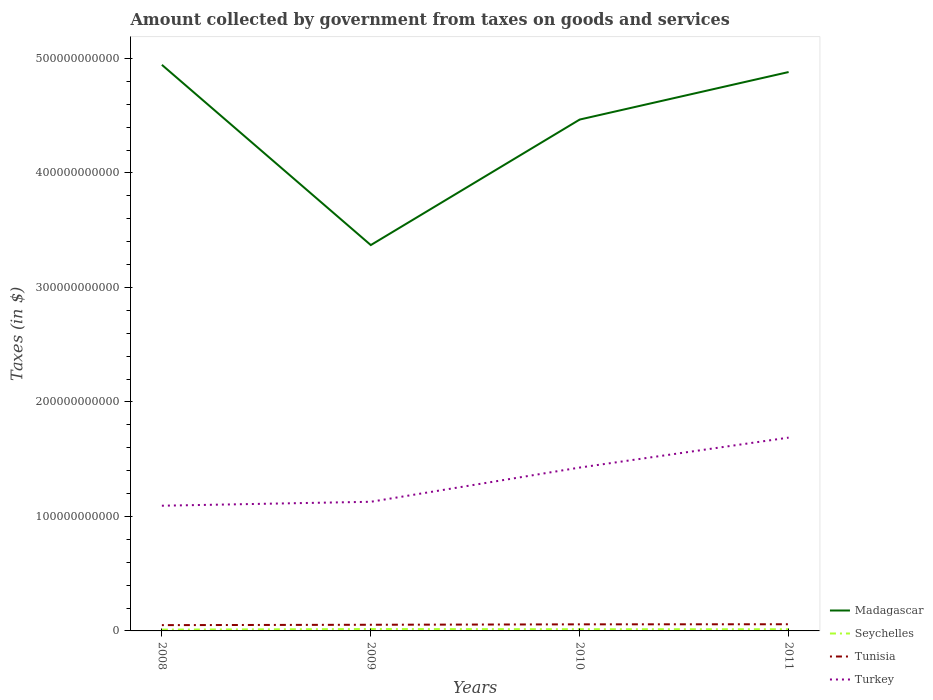Is the number of lines equal to the number of legend labels?
Provide a short and direct response. Yes. Across all years, what is the maximum amount collected by government from taxes on goods and services in Tunisia?
Your answer should be compact. 5.06e+09. In which year was the amount collected by government from taxes on goods and services in Madagascar maximum?
Your response must be concise. 2009. What is the total amount collected by government from taxes on goods and services in Turkey in the graph?
Your answer should be compact. -2.99e+1. What is the difference between the highest and the second highest amount collected by government from taxes on goods and services in Tunisia?
Give a very brief answer. 7.66e+08. How many lines are there?
Your answer should be compact. 4. How many years are there in the graph?
Make the answer very short. 4. What is the difference between two consecutive major ticks on the Y-axis?
Offer a very short reply. 1.00e+11. Does the graph contain any zero values?
Keep it short and to the point. No. Does the graph contain grids?
Provide a short and direct response. No. How many legend labels are there?
Offer a very short reply. 4. What is the title of the graph?
Provide a succinct answer. Amount collected by government from taxes on goods and services. Does "Congo (Republic)" appear as one of the legend labels in the graph?
Your answer should be very brief. No. What is the label or title of the Y-axis?
Provide a succinct answer. Taxes (in $). What is the Taxes (in $) of Madagascar in 2008?
Your answer should be very brief. 4.94e+11. What is the Taxes (in $) in Seychelles in 2008?
Give a very brief answer. 1.15e+09. What is the Taxes (in $) in Tunisia in 2008?
Offer a terse response. 5.06e+09. What is the Taxes (in $) of Turkey in 2008?
Provide a short and direct response. 1.09e+11. What is the Taxes (in $) in Madagascar in 2009?
Ensure brevity in your answer.  3.37e+11. What is the Taxes (in $) of Seychelles in 2009?
Make the answer very short. 1.66e+09. What is the Taxes (in $) of Tunisia in 2009?
Ensure brevity in your answer.  5.38e+09. What is the Taxes (in $) of Turkey in 2009?
Your answer should be compact. 1.13e+11. What is the Taxes (in $) of Madagascar in 2010?
Your answer should be very brief. 4.47e+11. What is the Taxes (in $) of Seychelles in 2010?
Ensure brevity in your answer.  1.51e+09. What is the Taxes (in $) of Tunisia in 2010?
Ensure brevity in your answer.  5.75e+09. What is the Taxes (in $) in Turkey in 2010?
Your answer should be very brief. 1.43e+11. What is the Taxes (in $) in Madagascar in 2011?
Make the answer very short. 4.88e+11. What is the Taxes (in $) of Seychelles in 2011?
Provide a short and direct response. 1.48e+09. What is the Taxes (in $) in Tunisia in 2011?
Your answer should be compact. 5.83e+09. What is the Taxes (in $) in Turkey in 2011?
Keep it short and to the point. 1.69e+11. Across all years, what is the maximum Taxes (in $) of Madagascar?
Offer a terse response. 4.94e+11. Across all years, what is the maximum Taxes (in $) in Seychelles?
Make the answer very short. 1.66e+09. Across all years, what is the maximum Taxes (in $) in Tunisia?
Ensure brevity in your answer.  5.83e+09. Across all years, what is the maximum Taxes (in $) in Turkey?
Offer a very short reply. 1.69e+11. Across all years, what is the minimum Taxes (in $) of Madagascar?
Make the answer very short. 3.37e+11. Across all years, what is the minimum Taxes (in $) in Seychelles?
Give a very brief answer. 1.15e+09. Across all years, what is the minimum Taxes (in $) of Tunisia?
Provide a succinct answer. 5.06e+09. Across all years, what is the minimum Taxes (in $) of Turkey?
Your answer should be very brief. 1.09e+11. What is the total Taxes (in $) in Madagascar in the graph?
Offer a very short reply. 1.77e+12. What is the total Taxes (in $) of Seychelles in the graph?
Your response must be concise. 5.80e+09. What is the total Taxes (in $) of Tunisia in the graph?
Ensure brevity in your answer.  2.20e+1. What is the total Taxes (in $) of Turkey in the graph?
Keep it short and to the point. 5.34e+11. What is the difference between the Taxes (in $) of Madagascar in 2008 and that in 2009?
Provide a short and direct response. 1.57e+11. What is the difference between the Taxes (in $) in Seychelles in 2008 and that in 2009?
Provide a short and direct response. -5.13e+08. What is the difference between the Taxes (in $) of Tunisia in 2008 and that in 2009?
Give a very brief answer. -3.16e+08. What is the difference between the Taxes (in $) of Turkey in 2008 and that in 2009?
Your answer should be compact. -3.44e+09. What is the difference between the Taxes (in $) of Madagascar in 2008 and that in 2010?
Keep it short and to the point. 4.78e+1. What is the difference between the Taxes (in $) of Seychelles in 2008 and that in 2010?
Your answer should be compact. -3.64e+08. What is the difference between the Taxes (in $) in Tunisia in 2008 and that in 2010?
Your answer should be very brief. -6.86e+08. What is the difference between the Taxes (in $) of Turkey in 2008 and that in 2010?
Make the answer very short. -3.33e+1. What is the difference between the Taxes (in $) of Madagascar in 2008 and that in 2011?
Your answer should be compact. 6.30e+09. What is the difference between the Taxes (in $) of Seychelles in 2008 and that in 2011?
Ensure brevity in your answer.  -3.36e+08. What is the difference between the Taxes (in $) of Tunisia in 2008 and that in 2011?
Offer a very short reply. -7.66e+08. What is the difference between the Taxes (in $) in Turkey in 2008 and that in 2011?
Your response must be concise. -5.95e+1. What is the difference between the Taxes (in $) of Madagascar in 2009 and that in 2010?
Keep it short and to the point. -1.10e+11. What is the difference between the Taxes (in $) in Seychelles in 2009 and that in 2010?
Offer a very short reply. 1.49e+08. What is the difference between the Taxes (in $) in Tunisia in 2009 and that in 2010?
Give a very brief answer. -3.70e+08. What is the difference between the Taxes (in $) in Turkey in 2009 and that in 2010?
Provide a short and direct response. -2.99e+1. What is the difference between the Taxes (in $) of Madagascar in 2009 and that in 2011?
Your answer should be compact. -1.51e+11. What is the difference between the Taxes (in $) of Seychelles in 2009 and that in 2011?
Your answer should be very brief. 1.77e+08. What is the difference between the Taxes (in $) in Tunisia in 2009 and that in 2011?
Keep it short and to the point. -4.50e+08. What is the difference between the Taxes (in $) of Turkey in 2009 and that in 2011?
Give a very brief answer. -5.60e+1. What is the difference between the Taxes (in $) of Madagascar in 2010 and that in 2011?
Provide a short and direct response. -4.15e+1. What is the difference between the Taxes (in $) in Seychelles in 2010 and that in 2011?
Make the answer very short. 2.78e+07. What is the difference between the Taxes (in $) of Tunisia in 2010 and that in 2011?
Your answer should be compact. -7.98e+07. What is the difference between the Taxes (in $) of Turkey in 2010 and that in 2011?
Make the answer very short. -2.61e+1. What is the difference between the Taxes (in $) of Madagascar in 2008 and the Taxes (in $) of Seychelles in 2009?
Your response must be concise. 4.93e+11. What is the difference between the Taxes (in $) in Madagascar in 2008 and the Taxes (in $) in Tunisia in 2009?
Your response must be concise. 4.89e+11. What is the difference between the Taxes (in $) in Madagascar in 2008 and the Taxes (in $) in Turkey in 2009?
Make the answer very short. 3.82e+11. What is the difference between the Taxes (in $) in Seychelles in 2008 and the Taxes (in $) in Tunisia in 2009?
Offer a terse response. -4.23e+09. What is the difference between the Taxes (in $) of Seychelles in 2008 and the Taxes (in $) of Turkey in 2009?
Your answer should be very brief. -1.12e+11. What is the difference between the Taxes (in $) in Tunisia in 2008 and the Taxes (in $) in Turkey in 2009?
Keep it short and to the point. -1.08e+11. What is the difference between the Taxes (in $) in Madagascar in 2008 and the Taxes (in $) in Seychelles in 2010?
Your answer should be very brief. 4.93e+11. What is the difference between the Taxes (in $) in Madagascar in 2008 and the Taxes (in $) in Tunisia in 2010?
Make the answer very short. 4.89e+11. What is the difference between the Taxes (in $) in Madagascar in 2008 and the Taxes (in $) in Turkey in 2010?
Offer a terse response. 3.52e+11. What is the difference between the Taxes (in $) in Seychelles in 2008 and the Taxes (in $) in Tunisia in 2010?
Make the answer very short. -4.60e+09. What is the difference between the Taxes (in $) of Seychelles in 2008 and the Taxes (in $) of Turkey in 2010?
Your answer should be very brief. -1.42e+11. What is the difference between the Taxes (in $) of Tunisia in 2008 and the Taxes (in $) of Turkey in 2010?
Your response must be concise. -1.38e+11. What is the difference between the Taxes (in $) of Madagascar in 2008 and the Taxes (in $) of Seychelles in 2011?
Offer a very short reply. 4.93e+11. What is the difference between the Taxes (in $) of Madagascar in 2008 and the Taxes (in $) of Tunisia in 2011?
Your answer should be compact. 4.89e+11. What is the difference between the Taxes (in $) in Madagascar in 2008 and the Taxes (in $) in Turkey in 2011?
Give a very brief answer. 3.26e+11. What is the difference between the Taxes (in $) of Seychelles in 2008 and the Taxes (in $) of Tunisia in 2011?
Offer a terse response. -4.68e+09. What is the difference between the Taxes (in $) of Seychelles in 2008 and the Taxes (in $) of Turkey in 2011?
Offer a very short reply. -1.68e+11. What is the difference between the Taxes (in $) of Tunisia in 2008 and the Taxes (in $) of Turkey in 2011?
Offer a very short reply. -1.64e+11. What is the difference between the Taxes (in $) in Madagascar in 2009 and the Taxes (in $) in Seychelles in 2010?
Keep it short and to the point. 3.35e+11. What is the difference between the Taxes (in $) in Madagascar in 2009 and the Taxes (in $) in Tunisia in 2010?
Your answer should be compact. 3.31e+11. What is the difference between the Taxes (in $) of Madagascar in 2009 and the Taxes (in $) of Turkey in 2010?
Offer a terse response. 1.94e+11. What is the difference between the Taxes (in $) in Seychelles in 2009 and the Taxes (in $) in Tunisia in 2010?
Offer a very short reply. -4.09e+09. What is the difference between the Taxes (in $) in Seychelles in 2009 and the Taxes (in $) in Turkey in 2010?
Offer a very short reply. -1.41e+11. What is the difference between the Taxes (in $) in Tunisia in 2009 and the Taxes (in $) in Turkey in 2010?
Provide a short and direct response. -1.37e+11. What is the difference between the Taxes (in $) of Madagascar in 2009 and the Taxes (in $) of Seychelles in 2011?
Provide a short and direct response. 3.35e+11. What is the difference between the Taxes (in $) in Madagascar in 2009 and the Taxes (in $) in Tunisia in 2011?
Provide a short and direct response. 3.31e+11. What is the difference between the Taxes (in $) of Madagascar in 2009 and the Taxes (in $) of Turkey in 2011?
Offer a very short reply. 1.68e+11. What is the difference between the Taxes (in $) of Seychelles in 2009 and the Taxes (in $) of Tunisia in 2011?
Offer a very short reply. -4.17e+09. What is the difference between the Taxes (in $) in Seychelles in 2009 and the Taxes (in $) in Turkey in 2011?
Ensure brevity in your answer.  -1.67e+11. What is the difference between the Taxes (in $) in Tunisia in 2009 and the Taxes (in $) in Turkey in 2011?
Provide a short and direct response. -1.63e+11. What is the difference between the Taxes (in $) in Madagascar in 2010 and the Taxes (in $) in Seychelles in 2011?
Offer a terse response. 4.45e+11. What is the difference between the Taxes (in $) of Madagascar in 2010 and the Taxes (in $) of Tunisia in 2011?
Your answer should be compact. 4.41e+11. What is the difference between the Taxes (in $) in Madagascar in 2010 and the Taxes (in $) in Turkey in 2011?
Provide a succinct answer. 2.78e+11. What is the difference between the Taxes (in $) in Seychelles in 2010 and the Taxes (in $) in Tunisia in 2011?
Offer a very short reply. -4.32e+09. What is the difference between the Taxes (in $) in Seychelles in 2010 and the Taxes (in $) in Turkey in 2011?
Provide a short and direct response. -1.67e+11. What is the difference between the Taxes (in $) of Tunisia in 2010 and the Taxes (in $) of Turkey in 2011?
Provide a short and direct response. -1.63e+11. What is the average Taxes (in $) in Madagascar per year?
Keep it short and to the point. 4.42e+11. What is the average Taxes (in $) in Seychelles per year?
Your answer should be very brief. 1.45e+09. What is the average Taxes (in $) of Tunisia per year?
Provide a short and direct response. 5.50e+09. What is the average Taxes (in $) of Turkey per year?
Provide a succinct answer. 1.33e+11. In the year 2008, what is the difference between the Taxes (in $) in Madagascar and Taxes (in $) in Seychelles?
Your answer should be compact. 4.93e+11. In the year 2008, what is the difference between the Taxes (in $) of Madagascar and Taxes (in $) of Tunisia?
Make the answer very short. 4.89e+11. In the year 2008, what is the difference between the Taxes (in $) of Madagascar and Taxes (in $) of Turkey?
Offer a terse response. 3.85e+11. In the year 2008, what is the difference between the Taxes (in $) of Seychelles and Taxes (in $) of Tunisia?
Provide a short and direct response. -3.91e+09. In the year 2008, what is the difference between the Taxes (in $) in Seychelles and Taxes (in $) in Turkey?
Your response must be concise. -1.08e+11. In the year 2008, what is the difference between the Taxes (in $) of Tunisia and Taxes (in $) of Turkey?
Offer a very short reply. -1.04e+11. In the year 2009, what is the difference between the Taxes (in $) of Madagascar and Taxes (in $) of Seychelles?
Ensure brevity in your answer.  3.35e+11. In the year 2009, what is the difference between the Taxes (in $) in Madagascar and Taxes (in $) in Tunisia?
Ensure brevity in your answer.  3.32e+11. In the year 2009, what is the difference between the Taxes (in $) in Madagascar and Taxes (in $) in Turkey?
Your response must be concise. 2.24e+11. In the year 2009, what is the difference between the Taxes (in $) of Seychelles and Taxes (in $) of Tunisia?
Your response must be concise. -3.72e+09. In the year 2009, what is the difference between the Taxes (in $) in Seychelles and Taxes (in $) in Turkey?
Your answer should be compact. -1.11e+11. In the year 2009, what is the difference between the Taxes (in $) in Tunisia and Taxes (in $) in Turkey?
Give a very brief answer. -1.07e+11. In the year 2010, what is the difference between the Taxes (in $) in Madagascar and Taxes (in $) in Seychelles?
Provide a succinct answer. 4.45e+11. In the year 2010, what is the difference between the Taxes (in $) of Madagascar and Taxes (in $) of Tunisia?
Your answer should be compact. 4.41e+11. In the year 2010, what is the difference between the Taxes (in $) of Madagascar and Taxes (in $) of Turkey?
Give a very brief answer. 3.04e+11. In the year 2010, what is the difference between the Taxes (in $) in Seychelles and Taxes (in $) in Tunisia?
Give a very brief answer. -4.24e+09. In the year 2010, what is the difference between the Taxes (in $) of Seychelles and Taxes (in $) of Turkey?
Your answer should be compact. -1.41e+11. In the year 2010, what is the difference between the Taxes (in $) in Tunisia and Taxes (in $) in Turkey?
Ensure brevity in your answer.  -1.37e+11. In the year 2011, what is the difference between the Taxes (in $) of Madagascar and Taxes (in $) of Seychelles?
Offer a terse response. 4.87e+11. In the year 2011, what is the difference between the Taxes (in $) in Madagascar and Taxes (in $) in Tunisia?
Offer a terse response. 4.82e+11. In the year 2011, what is the difference between the Taxes (in $) in Madagascar and Taxes (in $) in Turkey?
Make the answer very short. 3.19e+11. In the year 2011, what is the difference between the Taxes (in $) in Seychelles and Taxes (in $) in Tunisia?
Keep it short and to the point. -4.34e+09. In the year 2011, what is the difference between the Taxes (in $) of Seychelles and Taxes (in $) of Turkey?
Your answer should be very brief. -1.67e+11. In the year 2011, what is the difference between the Taxes (in $) of Tunisia and Taxes (in $) of Turkey?
Make the answer very short. -1.63e+11. What is the ratio of the Taxes (in $) in Madagascar in 2008 to that in 2009?
Provide a succinct answer. 1.47. What is the ratio of the Taxes (in $) in Seychelles in 2008 to that in 2009?
Your response must be concise. 0.69. What is the ratio of the Taxes (in $) of Tunisia in 2008 to that in 2009?
Provide a succinct answer. 0.94. What is the ratio of the Taxes (in $) of Turkey in 2008 to that in 2009?
Provide a short and direct response. 0.97. What is the ratio of the Taxes (in $) in Madagascar in 2008 to that in 2010?
Your answer should be very brief. 1.11. What is the ratio of the Taxes (in $) of Seychelles in 2008 to that in 2010?
Ensure brevity in your answer.  0.76. What is the ratio of the Taxes (in $) of Tunisia in 2008 to that in 2010?
Your answer should be compact. 0.88. What is the ratio of the Taxes (in $) of Turkey in 2008 to that in 2010?
Make the answer very short. 0.77. What is the ratio of the Taxes (in $) of Madagascar in 2008 to that in 2011?
Your answer should be compact. 1.01. What is the ratio of the Taxes (in $) of Seychelles in 2008 to that in 2011?
Provide a short and direct response. 0.77. What is the ratio of the Taxes (in $) of Tunisia in 2008 to that in 2011?
Offer a very short reply. 0.87. What is the ratio of the Taxes (in $) in Turkey in 2008 to that in 2011?
Make the answer very short. 0.65. What is the ratio of the Taxes (in $) in Madagascar in 2009 to that in 2010?
Give a very brief answer. 0.75. What is the ratio of the Taxes (in $) in Seychelles in 2009 to that in 2010?
Your response must be concise. 1.1. What is the ratio of the Taxes (in $) in Tunisia in 2009 to that in 2010?
Provide a short and direct response. 0.94. What is the ratio of the Taxes (in $) in Turkey in 2009 to that in 2010?
Give a very brief answer. 0.79. What is the ratio of the Taxes (in $) of Madagascar in 2009 to that in 2011?
Keep it short and to the point. 0.69. What is the ratio of the Taxes (in $) of Seychelles in 2009 to that in 2011?
Make the answer very short. 1.12. What is the ratio of the Taxes (in $) in Tunisia in 2009 to that in 2011?
Keep it short and to the point. 0.92. What is the ratio of the Taxes (in $) of Turkey in 2009 to that in 2011?
Provide a succinct answer. 0.67. What is the ratio of the Taxes (in $) of Madagascar in 2010 to that in 2011?
Provide a succinct answer. 0.92. What is the ratio of the Taxes (in $) of Seychelles in 2010 to that in 2011?
Provide a short and direct response. 1.02. What is the ratio of the Taxes (in $) in Tunisia in 2010 to that in 2011?
Your answer should be compact. 0.99. What is the ratio of the Taxes (in $) of Turkey in 2010 to that in 2011?
Ensure brevity in your answer.  0.85. What is the difference between the highest and the second highest Taxes (in $) in Madagascar?
Offer a terse response. 6.30e+09. What is the difference between the highest and the second highest Taxes (in $) of Seychelles?
Offer a very short reply. 1.49e+08. What is the difference between the highest and the second highest Taxes (in $) of Tunisia?
Give a very brief answer. 7.98e+07. What is the difference between the highest and the second highest Taxes (in $) in Turkey?
Keep it short and to the point. 2.61e+1. What is the difference between the highest and the lowest Taxes (in $) of Madagascar?
Offer a terse response. 1.57e+11. What is the difference between the highest and the lowest Taxes (in $) in Seychelles?
Ensure brevity in your answer.  5.13e+08. What is the difference between the highest and the lowest Taxes (in $) in Tunisia?
Provide a succinct answer. 7.66e+08. What is the difference between the highest and the lowest Taxes (in $) of Turkey?
Make the answer very short. 5.95e+1. 